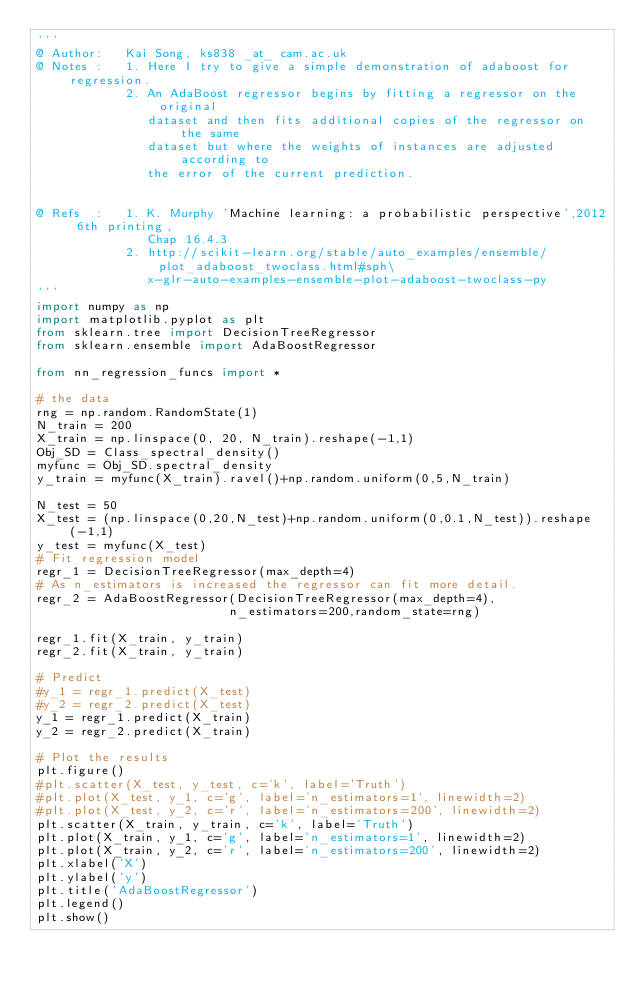<code> <loc_0><loc_0><loc_500><loc_500><_Python_>'''
@ Author:   Kai Song, ks838 _at_ cam.ac.uk
@ Notes :   1. Here I try to give a simple demonstration of adaboost for regression. 
            2. An AdaBoost regressor begins by fitting a regressor on the original 
               dataset and then fits additional copies of the regressor on the same 
               dataset but where the weights of instances are adjusted according to 
               the error of the current prediction.

           
@ Refs  :   1. K. Murphy 'Machine learning: a probabilistic perspective',2012 6th printing,
               Chap 16.4.3
            2. http://scikit-learn.org/stable/auto_examples/ensemble/plot_adaboost_twoclass.html#sph\
               x-glr-auto-examples-ensemble-plot-adaboost-twoclass-py
'''
import numpy as np
import matplotlib.pyplot as plt
from sklearn.tree import DecisionTreeRegressor
from sklearn.ensemble import AdaBoostRegressor

from nn_regression_funcs import *

# the data
rng = np.random.RandomState(1)
N_train = 200
X_train = np.linspace(0, 20, N_train).reshape(-1,1)
Obj_SD = Class_spectral_density()
myfunc = Obj_SD.spectral_density
y_train = myfunc(X_train).ravel()+np.random.uniform(0,5,N_train)

N_test = 50
X_test = (np.linspace(0,20,N_test)+np.random.uniform(0,0.1,N_test)).reshape(-1,1)
y_test = myfunc(X_test)
# Fit regression model
regr_1 = DecisionTreeRegressor(max_depth=4)
# As n_estimators is increased the regressor can fit more detail.
regr_2 = AdaBoostRegressor(DecisionTreeRegressor(max_depth=4),
                          n_estimators=200,random_state=rng)

regr_1.fit(X_train, y_train)
regr_2.fit(X_train, y_train)

# Predict
#y_1 = regr_1.predict(X_test)
#y_2 = regr_2.predict(X_test)
y_1 = regr_1.predict(X_train)
y_2 = regr_2.predict(X_train)

# Plot the results
plt.figure()
#plt.scatter(X_test, y_test, c='k', label='Truth')
#plt.plot(X_test, y_1, c='g', label='n_estimators=1', linewidth=2)
#plt.plot(X_test, y_2, c='r', label='n_estimators=200', linewidth=2)
plt.scatter(X_train, y_train, c='k', label='Truth')
plt.plot(X_train, y_1, c='g', label='n_estimators=1', linewidth=2)
plt.plot(X_train, y_2, c='r', label='n_estimators=200', linewidth=2)
plt.xlabel('X')
plt.ylabel('y')
plt.title('AdaBoostRegressor')
plt.legend()
plt.show()</code> 